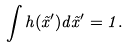Convert formula to latex. <formula><loc_0><loc_0><loc_500><loc_500>\int h ( \tilde { x } ^ { \prime } ) d \tilde { x } ^ { \prime } = 1 .</formula> 